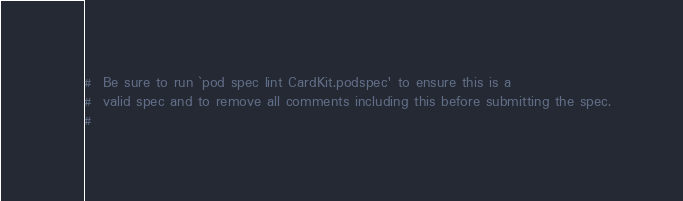Convert code to text. <code><loc_0><loc_0><loc_500><loc_500><_Ruby_>#  Be sure to run `pod spec lint CardKit.podspec' to ensure this is a
#  valid spec and to remove all comments including this before submitting the spec.
#</code> 